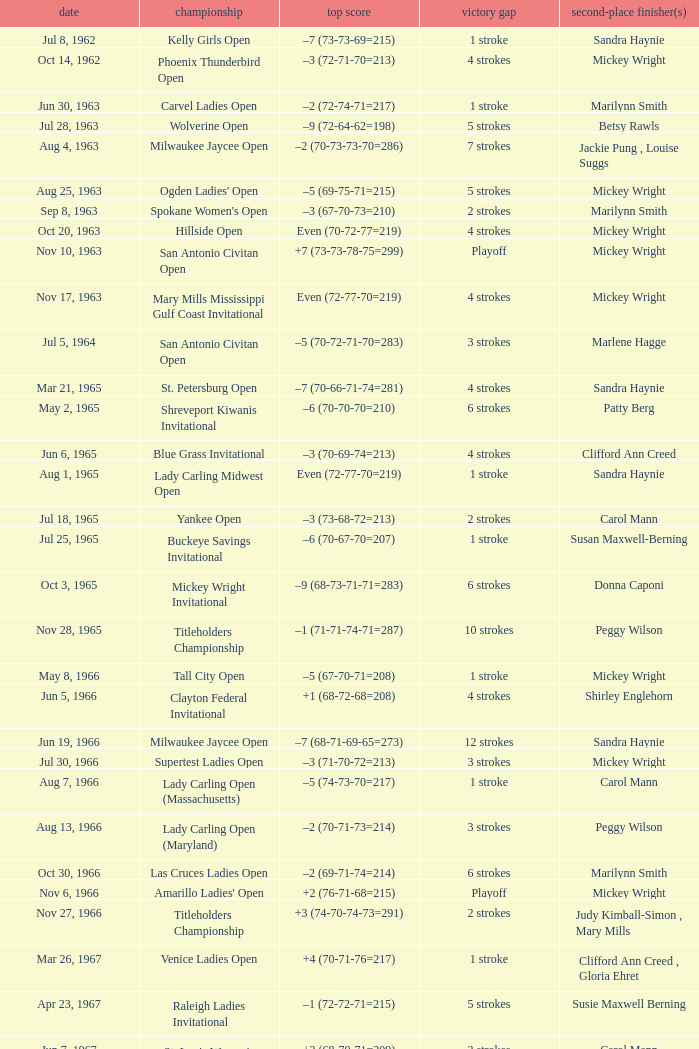What was the winning score when there were 9 strokes advantage? –7 (73-68-73-67=281). 